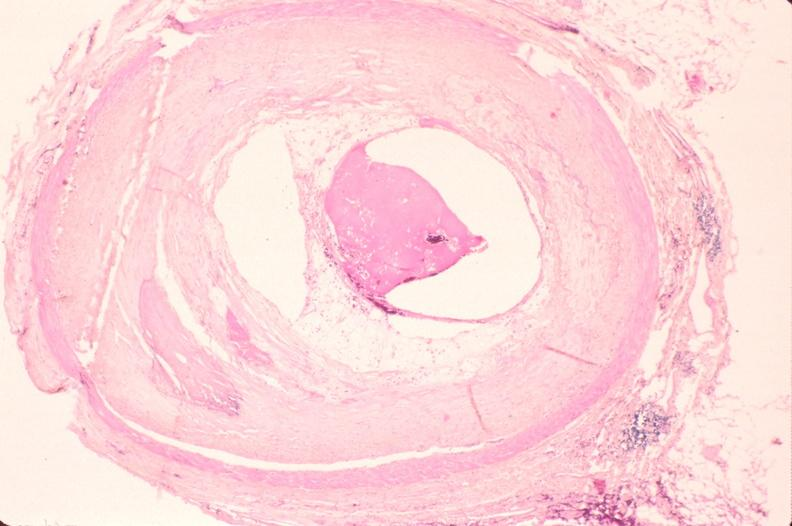what is present?
Answer the question using a single word or phrase. Cardiovascular 